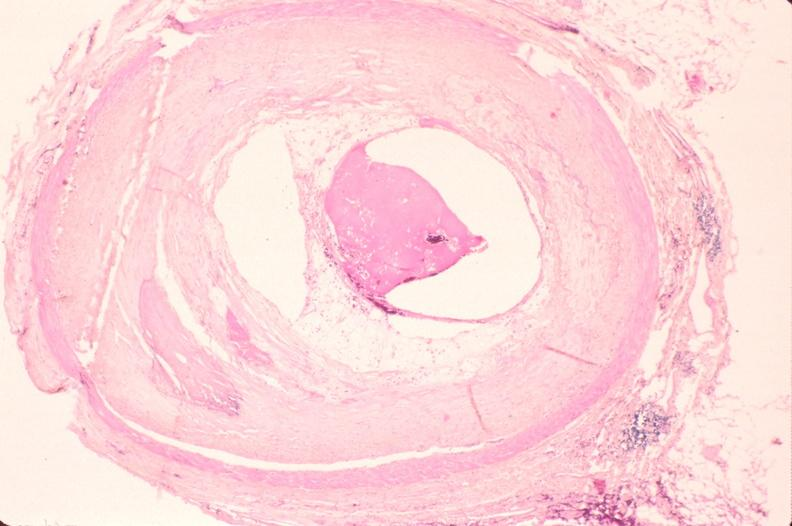what is present?
Answer the question using a single word or phrase. Cardiovascular 